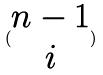<formula> <loc_0><loc_0><loc_500><loc_500>( \begin{matrix} n - 1 \\ i \end{matrix} )</formula> 